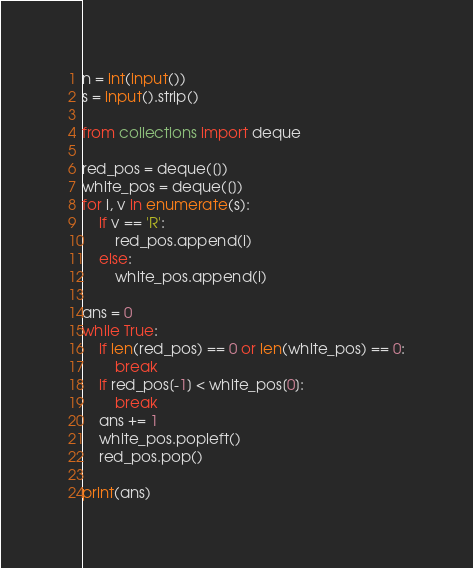Convert code to text. <code><loc_0><loc_0><loc_500><loc_500><_Python_>
n = int(input())
s = input().strip()

from collections import deque

red_pos = deque([])
white_pos = deque([])
for i, v in enumerate(s):
    if v == 'R':
        red_pos.append(i)
    else:
        white_pos.append(i)

ans = 0
while True:
    if len(red_pos) == 0 or len(white_pos) == 0:
        break
    if red_pos[-1] < white_pos[0]:
        break
    ans += 1
    white_pos.popleft()
    red_pos.pop()

print(ans)
</code> 